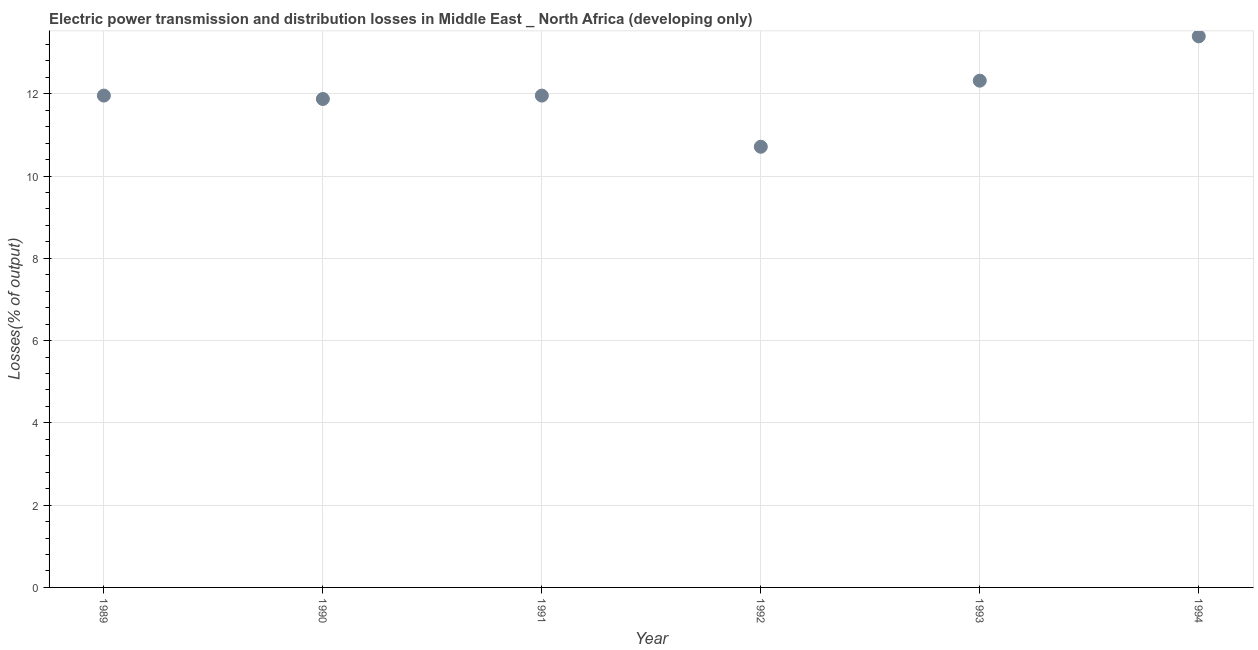What is the electric power transmission and distribution losses in 1992?
Make the answer very short. 10.71. Across all years, what is the maximum electric power transmission and distribution losses?
Keep it short and to the point. 13.39. Across all years, what is the minimum electric power transmission and distribution losses?
Provide a succinct answer. 10.71. What is the sum of the electric power transmission and distribution losses?
Your response must be concise. 72.21. What is the difference between the electric power transmission and distribution losses in 1991 and 1992?
Offer a terse response. 1.24. What is the average electric power transmission and distribution losses per year?
Keep it short and to the point. 12.03. What is the median electric power transmission and distribution losses?
Keep it short and to the point. 11.95. What is the ratio of the electric power transmission and distribution losses in 1990 to that in 1993?
Your response must be concise. 0.96. Is the electric power transmission and distribution losses in 1990 less than that in 1993?
Offer a terse response. Yes. What is the difference between the highest and the second highest electric power transmission and distribution losses?
Your answer should be very brief. 1.08. Is the sum of the electric power transmission and distribution losses in 1992 and 1994 greater than the maximum electric power transmission and distribution losses across all years?
Offer a very short reply. Yes. What is the difference between the highest and the lowest electric power transmission and distribution losses?
Give a very brief answer. 2.68. In how many years, is the electric power transmission and distribution losses greater than the average electric power transmission and distribution losses taken over all years?
Your response must be concise. 2. Does the electric power transmission and distribution losses monotonically increase over the years?
Your response must be concise. No. How many dotlines are there?
Provide a short and direct response. 1. Are the values on the major ticks of Y-axis written in scientific E-notation?
Keep it short and to the point. No. Does the graph contain any zero values?
Your response must be concise. No. What is the title of the graph?
Give a very brief answer. Electric power transmission and distribution losses in Middle East _ North Africa (developing only). What is the label or title of the Y-axis?
Ensure brevity in your answer.  Losses(% of output). What is the Losses(% of output) in 1989?
Keep it short and to the point. 11.95. What is the Losses(% of output) in 1990?
Make the answer very short. 11.87. What is the Losses(% of output) in 1991?
Give a very brief answer. 11.95. What is the Losses(% of output) in 1992?
Your answer should be compact. 10.71. What is the Losses(% of output) in 1993?
Give a very brief answer. 12.32. What is the Losses(% of output) in 1994?
Your response must be concise. 13.39. What is the difference between the Losses(% of output) in 1989 and 1990?
Your answer should be compact. 0.08. What is the difference between the Losses(% of output) in 1989 and 1991?
Make the answer very short. 0. What is the difference between the Losses(% of output) in 1989 and 1992?
Keep it short and to the point. 1.24. What is the difference between the Losses(% of output) in 1989 and 1993?
Make the answer very short. -0.36. What is the difference between the Losses(% of output) in 1989 and 1994?
Your response must be concise. -1.44. What is the difference between the Losses(% of output) in 1990 and 1991?
Keep it short and to the point. -0.08. What is the difference between the Losses(% of output) in 1990 and 1992?
Make the answer very short. 1.16. What is the difference between the Losses(% of output) in 1990 and 1993?
Your answer should be very brief. -0.45. What is the difference between the Losses(% of output) in 1990 and 1994?
Your answer should be very brief. -1.52. What is the difference between the Losses(% of output) in 1991 and 1992?
Make the answer very short. 1.24. What is the difference between the Losses(% of output) in 1991 and 1993?
Your answer should be compact. -0.36. What is the difference between the Losses(% of output) in 1991 and 1994?
Offer a terse response. -1.44. What is the difference between the Losses(% of output) in 1992 and 1993?
Your answer should be compact. -1.61. What is the difference between the Losses(% of output) in 1992 and 1994?
Your answer should be very brief. -2.68. What is the difference between the Losses(% of output) in 1993 and 1994?
Your answer should be compact. -1.08. What is the ratio of the Losses(% of output) in 1989 to that in 1992?
Ensure brevity in your answer.  1.12. What is the ratio of the Losses(% of output) in 1989 to that in 1993?
Offer a very short reply. 0.97. What is the ratio of the Losses(% of output) in 1989 to that in 1994?
Provide a short and direct response. 0.89. What is the ratio of the Losses(% of output) in 1990 to that in 1991?
Provide a succinct answer. 0.99. What is the ratio of the Losses(% of output) in 1990 to that in 1992?
Give a very brief answer. 1.11. What is the ratio of the Losses(% of output) in 1990 to that in 1994?
Your response must be concise. 0.89. What is the ratio of the Losses(% of output) in 1991 to that in 1992?
Your answer should be compact. 1.12. What is the ratio of the Losses(% of output) in 1991 to that in 1994?
Your answer should be compact. 0.89. What is the ratio of the Losses(% of output) in 1992 to that in 1993?
Your answer should be very brief. 0.87. What is the ratio of the Losses(% of output) in 1993 to that in 1994?
Keep it short and to the point. 0.92. 